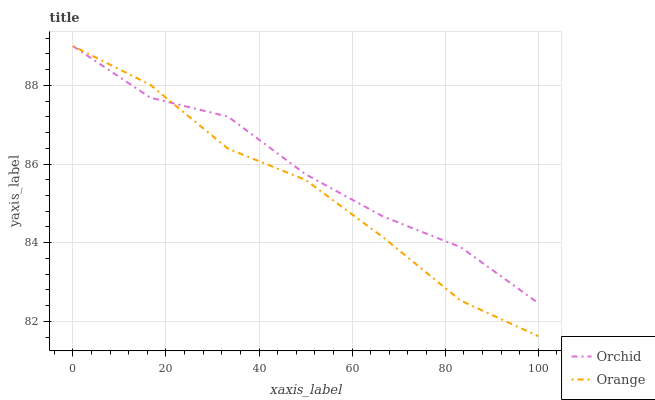Does Orange have the minimum area under the curve?
Answer yes or no. Yes. Does Orchid have the maximum area under the curve?
Answer yes or no. Yes. Does Orchid have the minimum area under the curve?
Answer yes or no. No. Is Orange the smoothest?
Answer yes or no. Yes. Is Orchid the roughest?
Answer yes or no. Yes. Is Orchid the smoothest?
Answer yes or no. No. Does Orange have the lowest value?
Answer yes or no. Yes. Does Orchid have the lowest value?
Answer yes or no. No. Does Orchid have the highest value?
Answer yes or no. Yes. Does Orchid intersect Orange?
Answer yes or no. Yes. Is Orchid less than Orange?
Answer yes or no. No. Is Orchid greater than Orange?
Answer yes or no. No. 